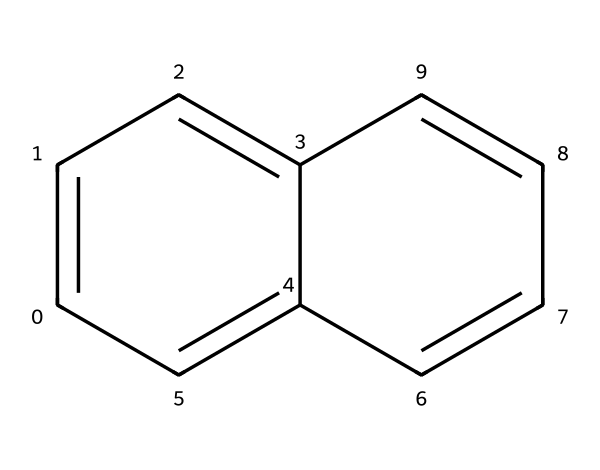What is the molecular formula of the compound represented? The structure contains Carbon (C) atoms. Counting the number of ring structures, there are a total of 12 Carbon atoms, with no other elements present. Therefore, the molecular formula is C12.
Answer: C12 How many rings are present in the structure? Analyzing the structure, it shows two interconnected rings that consist of carbon atoms. Each defined loop represents a ring. Thus, there are 2 rings.
Answer: 2 Is this compound considered aromatic? The structure consists of conjugated pi bonds forming rings with alternating double bonds, which indicates that it meets Huckel's rule (4n + 2 π electrons). Thus, it is considered aromatic.
Answer: yes Which part of the structure contributes to the electron stability? The presence of alternating double bonds in the rings allows for delocalization of electrons across the entire structure, which contributes to electron stability.
Answer: delocalized electrons What potential benefits can graphene quantum dots provide to concrete strength? Graphene quantum dots can enhance the mechanical properties of concrete by improving its tensile strength and durability due to their high surface area and bonding capabilities with cement compounds.
Answer: increased tensile strength How does the arrangement of atoms in graphene quantum dots influence concrete properties? The atomic arrangement in graphene quantum dots facilitates strong interactions with the cement matrix, leading to improved dispersion and better load-bearing capacity within the concrete, enhancing overall mechanical properties.
Answer: improved load-bearing capacity 